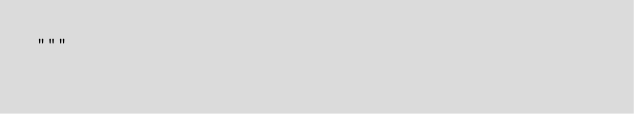Convert code to text. <code><loc_0><loc_0><loc_500><loc_500><_Python_>"""
</code> 